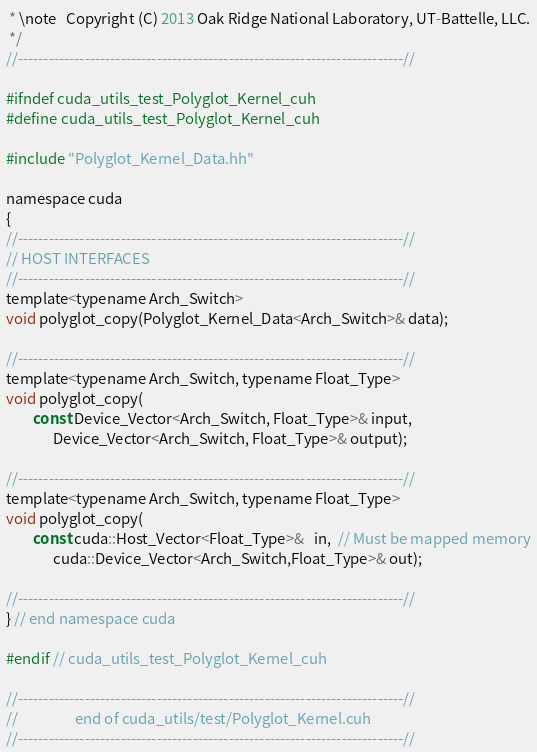Convert code to text. <code><loc_0><loc_0><loc_500><loc_500><_Cuda_> * \note   Copyright (C) 2013 Oak Ridge National Laboratory, UT-Battelle, LLC.
 */
//---------------------------------------------------------------------------//

#ifndef cuda_utils_test_Polyglot_Kernel_cuh
#define cuda_utils_test_Polyglot_Kernel_cuh

#include "Polyglot_Kernel_Data.hh"

namespace cuda
{
//---------------------------------------------------------------------------//
// HOST INTERFACES
//---------------------------------------------------------------------------//
template<typename Arch_Switch>
void polyglot_copy(Polyglot_Kernel_Data<Arch_Switch>& data);

//---------------------------------------------------------------------------//
template<typename Arch_Switch, typename Float_Type>
void polyglot_copy(
        const Device_Vector<Arch_Switch, Float_Type>& input,
              Device_Vector<Arch_Switch, Float_Type>& output);

//---------------------------------------------------------------------------//
template<typename Arch_Switch, typename Float_Type>
void polyglot_copy(
        const cuda::Host_Vector<Float_Type>&   in,  // Must be mapped memory
              cuda::Device_Vector<Arch_Switch,Float_Type>& out);

//---------------------------------------------------------------------------//
} // end namespace cuda

#endif // cuda_utils_test_Polyglot_Kernel_cuh

//---------------------------------------------------------------------------//
//                 end of cuda_utils/test/Polyglot_Kernel.cuh
//---------------------------------------------------------------------------//
</code> 